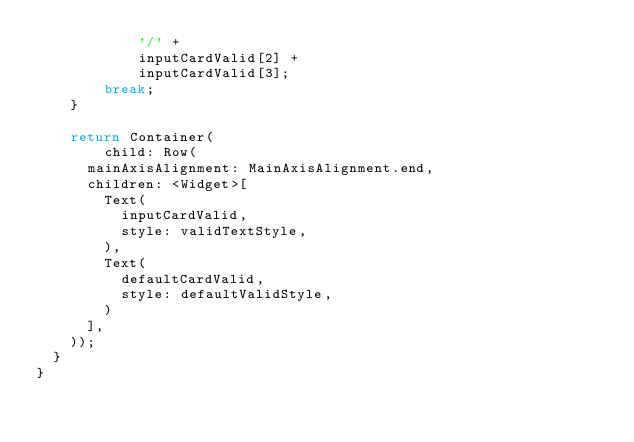Convert code to text. <code><loc_0><loc_0><loc_500><loc_500><_Dart_>            '/' +
            inputCardValid[2] +
            inputCardValid[3];
        break;
    }

    return Container(
        child: Row(
      mainAxisAlignment: MainAxisAlignment.end,
      children: <Widget>[
        Text(
          inputCardValid,
          style: validTextStyle,
        ),
        Text(
          defaultCardValid,
          style: defaultValidStyle,
        )
      ],
    ));
  }
}
</code> 